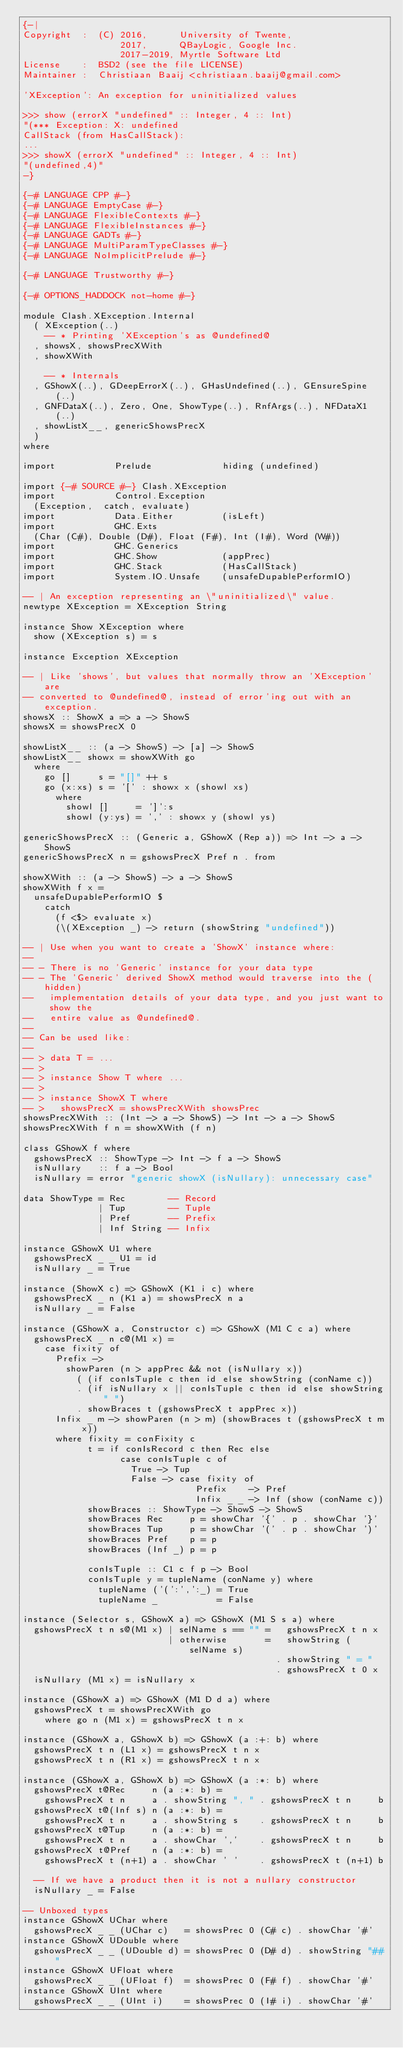<code> <loc_0><loc_0><loc_500><loc_500><_Haskell_>{-|
Copyright  :  (C) 2016,      University of Twente,
                  2017,      QBayLogic, Google Inc.
                  2017-2019, Myrtle Software Ltd
License    :  BSD2 (see the file LICENSE)
Maintainer :  Christiaan Baaij <christiaan.baaij@gmail.com>

'XException': An exception for uninitialized values

>>> show (errorX "undefined" :: Integer, 4 :: Int)
"(*** Exception: X: undefined
CallStack (from HasCallStack):
...
>>> showX (errorX "undefined" :: Integer, 4 :: Int)
"(undefined,4)"
-}

{-# LANGUAGE CPP #-}
{-# LANGUAGE EmptyCase #-}
{-# LANGUAGE FlexibleContexts #-}
{-# LANGUAGE FlexibleInstances #-}
{-# LANGUAGE GADTs #-}
{-# LANGUAGE MultiParamTypeClasses #-}
{-# LANGUAGE NoImplicitPrelude #-}

{-# LANGUAGE Trustworthy #-}

{-# OPTIONS_HADDOCK not-home #-}

module Clash.XException.Internal
  ( XException(..)
    -- * Printing 'XException's as @undefined@
  , showsX, showsPrecXWith
  , showXWith

    -- * Internals
  , GShowX(..), GDeepErrorX(..), GHasUndefined(..), GEnsureSpine(..)
  , GNFDataX(..), Zero, One, ShowType(..), RnfArgs(..), NFDataX1(..)
  , showListX__, genericShowsPrecX
  )
where

import           Prelude             hiding (undefined)

import {-# SOURCE #-} Clash.XException
import           Control.Exception
  (Exception,  catch, evaluate)
import           Data.Either         (isLeft)
import           GHC.Exts
  (Char (C#), Double (D#), Float (F#), Int (I#), Word (W#))
import           GHC.Generics
import           GHC.Show            (appPrec)
import           GHC.Stack           (HasCallStack)
import           System.IO.Unsafe    (unsafeDupablePerformIO)

-- | An exception representing an \"uninitialized\" value.
newtype XException = XException String

instance Show XException where
  show (XException s) = s

instance Exception XException

-- | Like 'shows', but values that normally throw an 'XException' are
-- converted to @undefined@, instead of error'ing out with an exception.
showsX :: ShowX a => a -> ShowS
showsX = showsPrecX 0

showListX__ :: (a -> ShowS) -> [a] -> ShowS
showListX__ showx = showXWith go
  where
    go []     s = "[]" ++ s
    go (x:xs) s = '[' : showx x (showl xs)
      where
        showl []     = ']':s
        showl (y:ys) = ',' : showx y (showl ys)

genericShowsPrecX :: (Generic a, GShowX (Rep a)) => Int -> a -> ShowS
genericShowsPrecX n = gshowsPrecX Pref n . from

showXWith :: (a -> ShowS) -> a -> ShowS
showXWith f x =
  unsafeDupablePerformIO $
    catch
      (f <$> evaluate x)
      (\(XException _) -> return (showString "undefined"))

-- | Use when you want to create a 'ShowX' instance where:
--
-- - There is no 'Generic' instance for your data type
-- - The 'Generic' derived ShowX method would traverse into the (hidden)
--   implementation details of your data type, and you just want to show the
--   entire value as @undefined@.
--
-- Can be used like:
--
-- > data T = ...
-- >
-- > instance Show T where ...
-- >
-- > instance ShowX T where
-- >   showsPrecX = showsPrecXWith showsPrec
showsPrecXWith :: (Int -> a -> ShowS) -> Int -> a -> ShowS
showsPrecXWith f n = showXWith (f n)

class GShowX f where
  gshowsPrecX :: ShowType -> Int -> f a -> ShowS
  isNullary   :: f a -> Bool
  isNullary = error "generic showX (isNullary): unnecessary case"

data ShowType = Rec        -- Record
              | Tup        -- Tuple
              | Pref       -- Prefix
              | Inf String -- Infix

instance GShowX U1 where
  gshowsPrecX _ _ U1 = id
  isNullary _ = True

instance (ShowX c) => GShowX (K1 i c) where
  gshowsPrecX _ n (K1 a) = showsPrecX n a
  isNullary _ = False

instance (GShowX a, Constructor c) => GShowX (M1 C c a) where
  gshowsPrecX _ n c@(M1 x) =
    case fixity of
      Prefix ->
        showParen (n > appPrec && not (isNullary x))
          ( (if conIsTuple c then id else showString (conName c))
          . (if isNullary x || conIsTuple c then id else showString " ")
          . showBraces t (gshowsPrecX t appPrec x))
      Infix _ m -> showParen (n > m) (showBraces t (gshowsPrecX t m x))
      where fixity = conFixity c
            t = if conIsRecord c then Rec else
                  case conIsTuple c of
                    True -> Tup
                    False -> case fixity of
                                Prefix    -> Pref
                                Infix _ _ -> Inf (show (conName c))
            showBraces :: ShowType -> ShowS -> ShowS
            showBraces Rec     p = showChar '{' . p . showChar '}'
            showBraces Tup     p = showChar '(' . p . showChar ')'
            showBraces Pref    p = p
            showBraces (Inf _) p = p

            conIsTuple :: C1 c f p -> Bool
            conIsTuple y = tupleName (conName y) where
              tupleName ('(':',':_) = True
              tupleName _           = False

instance (Selector s, GShowX a) => GShowX (M1 S s a) where
  gshowsPrecX t n s@(M1 x) | selName s == "" =   gshowsPrecX t n x
                           | otherwise       =   showString (selName s)
                                               . showString " = "
                                               . gshowsPrecX t 0 x
  isNullary (M1 x) = isNullary x

instance (GShowX a) => GShowX (M1 D d a) where
  gshowsPrecX t = showsPrecXWith go
    where go n (M1 x) = gshowsPrecX t n x

instance (GShowX a, GShowX b) => GShowX (a :+: b) where
  gshowsPrecX t n (L1 x) = gshowsPrecX t n x
  gshowsPrecX t n (R1 x) = gshowsPrecX t n x

instance (GShowX a, GShowX b) => GShowX (a :*: b) where
  gshowsPrecX t@Rec     n (a :*: b) =
    gshowsPrecX t n     a . showString ", " . gshowsPrecX t n     b
  gshowsPrecX t@(Inf s) n (a :*: b) =
    gshowsPrecX t n     a . showString s    . gshowsPrecX t n     b
  gshowsPrecX t@Tup     n (a :*: b) =
    gshowsPrecX t n     a . showChar ','    . gshowsPrecX t n     b
  gshowsPrecX t@Pref    n (a :*: b) =
    gshowsPrecX t (n+1) a . showChar ' '    . gshowsPrecX t (n+1) b

  -- If we have a product then it is not a nullary constructor
  isNullary _ = False

-- Unboxed types
instance GShowX UChar where
  gshowsPrecX _ _ (UChar c)   = showsPrec 0 (C# c) . showChar '#'
instance GShowX UDouble where
  gshowsPrecX _ _ (UDouble d) = showsPrec 0 (D# d) . showString "##"
instance GShowX UFloat where
  gshowsPrecX _ _ (UFloat f)  = showsPrec 0 (F# f) . showChar '#'
instance GShowX UInt where
  gshowsPrecX _ _ (UInt i)    = showsPrec 0 (I# i) . showChar '#'</code> 